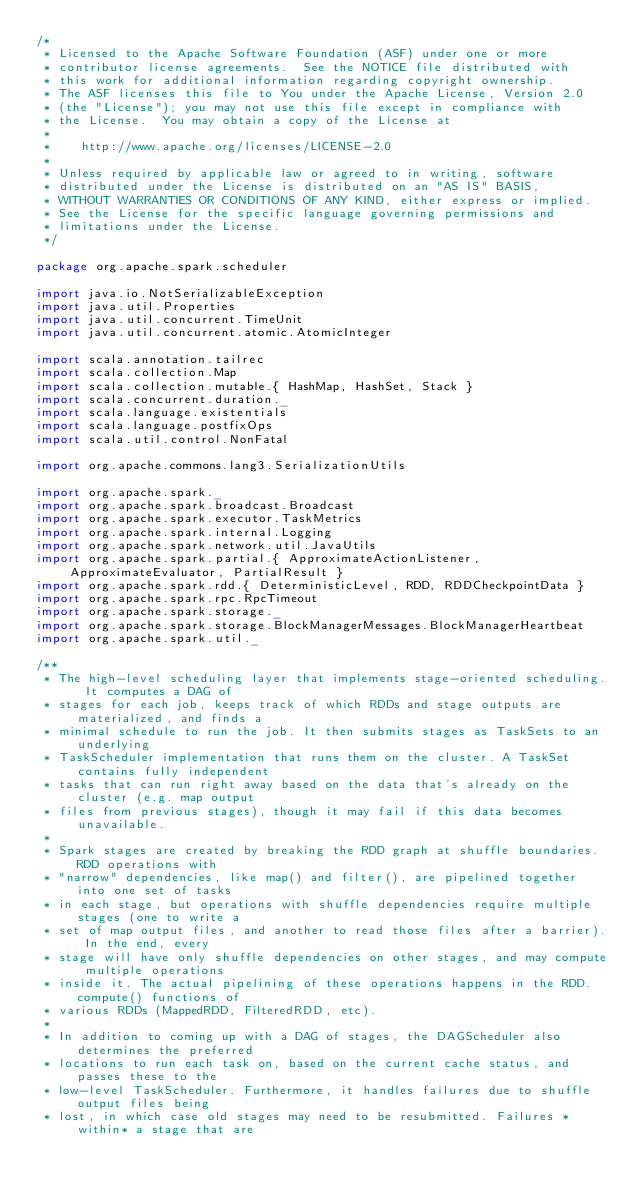Convert code to text. <code><loc_0><loc_0><loc_500><loc_500><_Scala_>/*
 * Licensed to the Apache Software Foundation (ASF) under one or more
 * contributor license agreements.  See the NOTICE file distributed with
 * this work for additional information regarding copyright ownership.
 * The ASF licenses this file to You under the Apache License, Version 2.0
 * (the "License"); you may not use this file except in compliance with
 * the License.  You may obtain a copy of the License at
 *
 *    http://www.apache.org/licenses/LICENSE-2.0
 *
 * Unless required by applicable law or agreed to in writing, software
 * distributed under the License is distributed on an "AS IS" BASIS,
 * WITHOUT WARRANTIES OR CONDITIONS OF ANY KIND, either express or implied.
 * See the License for the specific language governing permissions and
 * limitations under the License.
 */

package org.apache.spark.scheduler

import java.io.NotSerializableException
import java.util.Properties
import java.util.concurrent.TimeUnit
import java.util.concurrent.atomic.AtomicInteger

import scala.annotation.tailrec
import scala.collection.Map
import scala.collection.mutable.{ HashMap, HashSet, Stack }
import scala.concurrent.duration._
import scala.language.existentials
import scala.language.postfixOps
import scala.util.control.NonFatal

import org.apache.commons.lang3.SerializationUtils

import org.apache.spark._
import org.apache.spark.broadcast.Broadcast
import org.apache.spark.executor.TaskMetrics
import org.apache.spark.internal.Logging
import org.apache.spark.network.util.JavaUtils
import org.apache.spark.partial.{ ApproximateActionListener, ApproximateEvaluator, PartialResult }
import org.apache.spark.rdd.{ DeterministicLevel, RDD, RDDCheckpointData }
import org.apache.spark.rpc.RpcTimeout
import org.apache.spark.storage._
import org.apache.spark.storage.BlockManagerMessages.BlockManagerHeartbeat
import org.apache.spark.util._

/**
 * The high-level scheduling layer that implements stage-oriented scheduling. It computes a DAG of
 * stages for each job, keeps track of which RDDs and stage outputs are materialized, and finds a
 * minimal schedule to run the job. It then submits stages as TaskSets to an underlying
 * TaskScheduler implementation that runs them on the cluster. A TaskSet contains fully independent
 * tasks that can run right away based on the data that's already on the cluster (e.g. map output
 * files from previous stages), though it may fail if this data becomes unavailable.
 *
 * Spark stages are created by breaking the RDD graph at shuffle boundaries. RDD operations with
 * "narrow" dependencies, like map() and filter(), are pipelined together into one set of tasks
 * in each stage, but operations with shuffle dependencies require multiple stages (one to write a
 * set of map output files, and another to read those files after a barrier). In the end, every
 * stage will have only shuffle dependencies on other stages, and may compute multiple operations
 * inside it. The actual pipelining of these operations happens in the RDD.compute() functions of
 * various RDDs (MappedRDD, FilteredRDD, etc).
 *
 * In addition to coming up with a DAG of stages, the DAGScheduler also determines the preferred
 * locations to run each task on, based on the current cache status, and passes these to the
 * low-level TaskScheduler. Furthermore, it handles failures due to shuffle output files being
 * lost, in which case old stages may need to be resubmitted. Failures *within* a stage that are</code> 